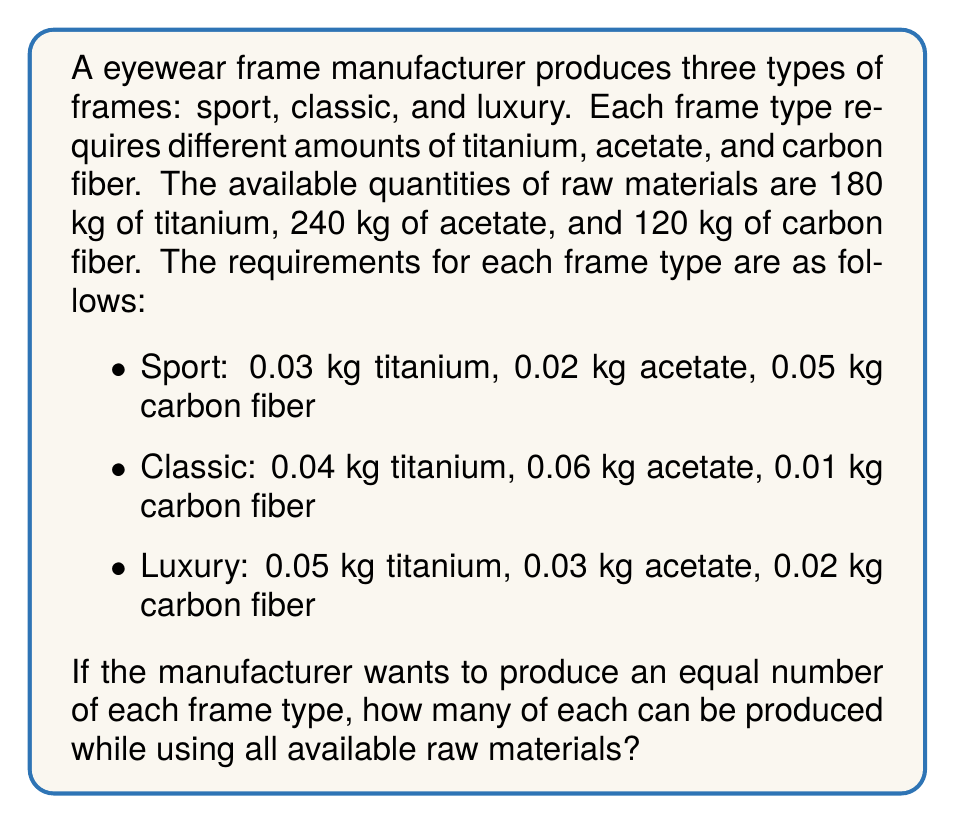Help me with this question. To solve this problem, we need to set up a system of equations based on the given information. Let $x$ be the number of each type of frame to be produced.

1. Set up the equations:
   For titanium: $0.03x + 0.04x + 0.05x = 180$
   For acetate: $0.02x + 0.06x + 0.03x = 240$
   For carbon fiber: $0.05x + 0.01x + 0.02x = 120$

2. Simplify the equations:
   Titanium: $0.12x = 180$
   Acetate: $0.11x = 240$
   Carbon fiber: $0.08x = 120$

3. Solve each equation for $x$:
   Titanium: $x = 180 / 0.12 = 1500$
   Acetate: $x = 240 / 0.11 \approx 2181.82$
   Carbon fiber: $x = 120 / 0.08 = 1500$

4. The smallest value of $x$ is 1500, which is determined by both the titanium and carbon fiber constraints. This means we can produce 1500 of each frame type.

5. Verify the solution:
   Titanium used: $1500 \times (0.03 + 0.04 + 0.05) = 1500 \times 0.12 = 180$ kg
   Acetate used: $1500 \times (0.02 + 0.06 + 0.03) = 1500 \times 0.11 = 165$ kg
   Carbon fiber used: $1500 \times (0.05 + 0.01 + 0.02) = 1500 \times 0.08 = 120$ kg

   All titanium and carbon fiber are used, but there is 75 kg of acetate left over.
Answer: The manufacturer can produce 1500 of each frame type (sport, classic, and luxury) while using all available titanium and carbon fiber. This will leave 75 kg of acetate unused. 